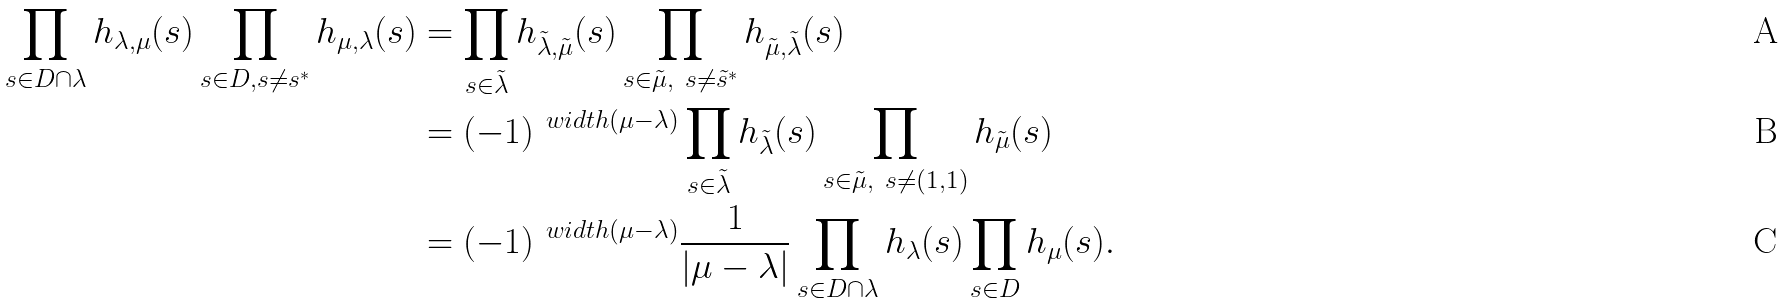Convert formula to latex. <formula><loc_0><loc_0><loc_500><loc_500>\prod _ { s \in D \cap \lambda } h _ { \lambda , \mu } ( s ) \prod _ { s \in D , s \ne s ^ { * } } h _ { \mu , \lambda } ( s ) & = \prod _ { s \in \tilde { \lambda } } h _ { \tilde { \lambda } , \tilde { \mu } } ( s ) \prod _ { s \in \tilde { \mu } , \ s \ne \tilde { s } ^ { * } } h _ { \tilde { \mu } , \tilde { \lambda } } ( s ) \\ & = ( - 1 ) ^ { \ w i d t h ( \mu - \lambda ) } \prod _ { s \in \tilde { \lambda } } h _ { \tilde { \lambda } } ( s ) \prod _ { s \in \tilde { \mu } , \ s \ne ( 1 , 1 ) } h _ { \tilde { \mu } } ( s ) \\ & = ( - 1 ) ^ { \ w i d t h ( \mu - \lambda ) } \frac { 1 } { | \mu - \lambda | } \prod _ { s \in D \cap \lambda } h _ { \lambda } ( s ) \prod _ { s \in D } h _ { \mu } ( s ) .</formula> 